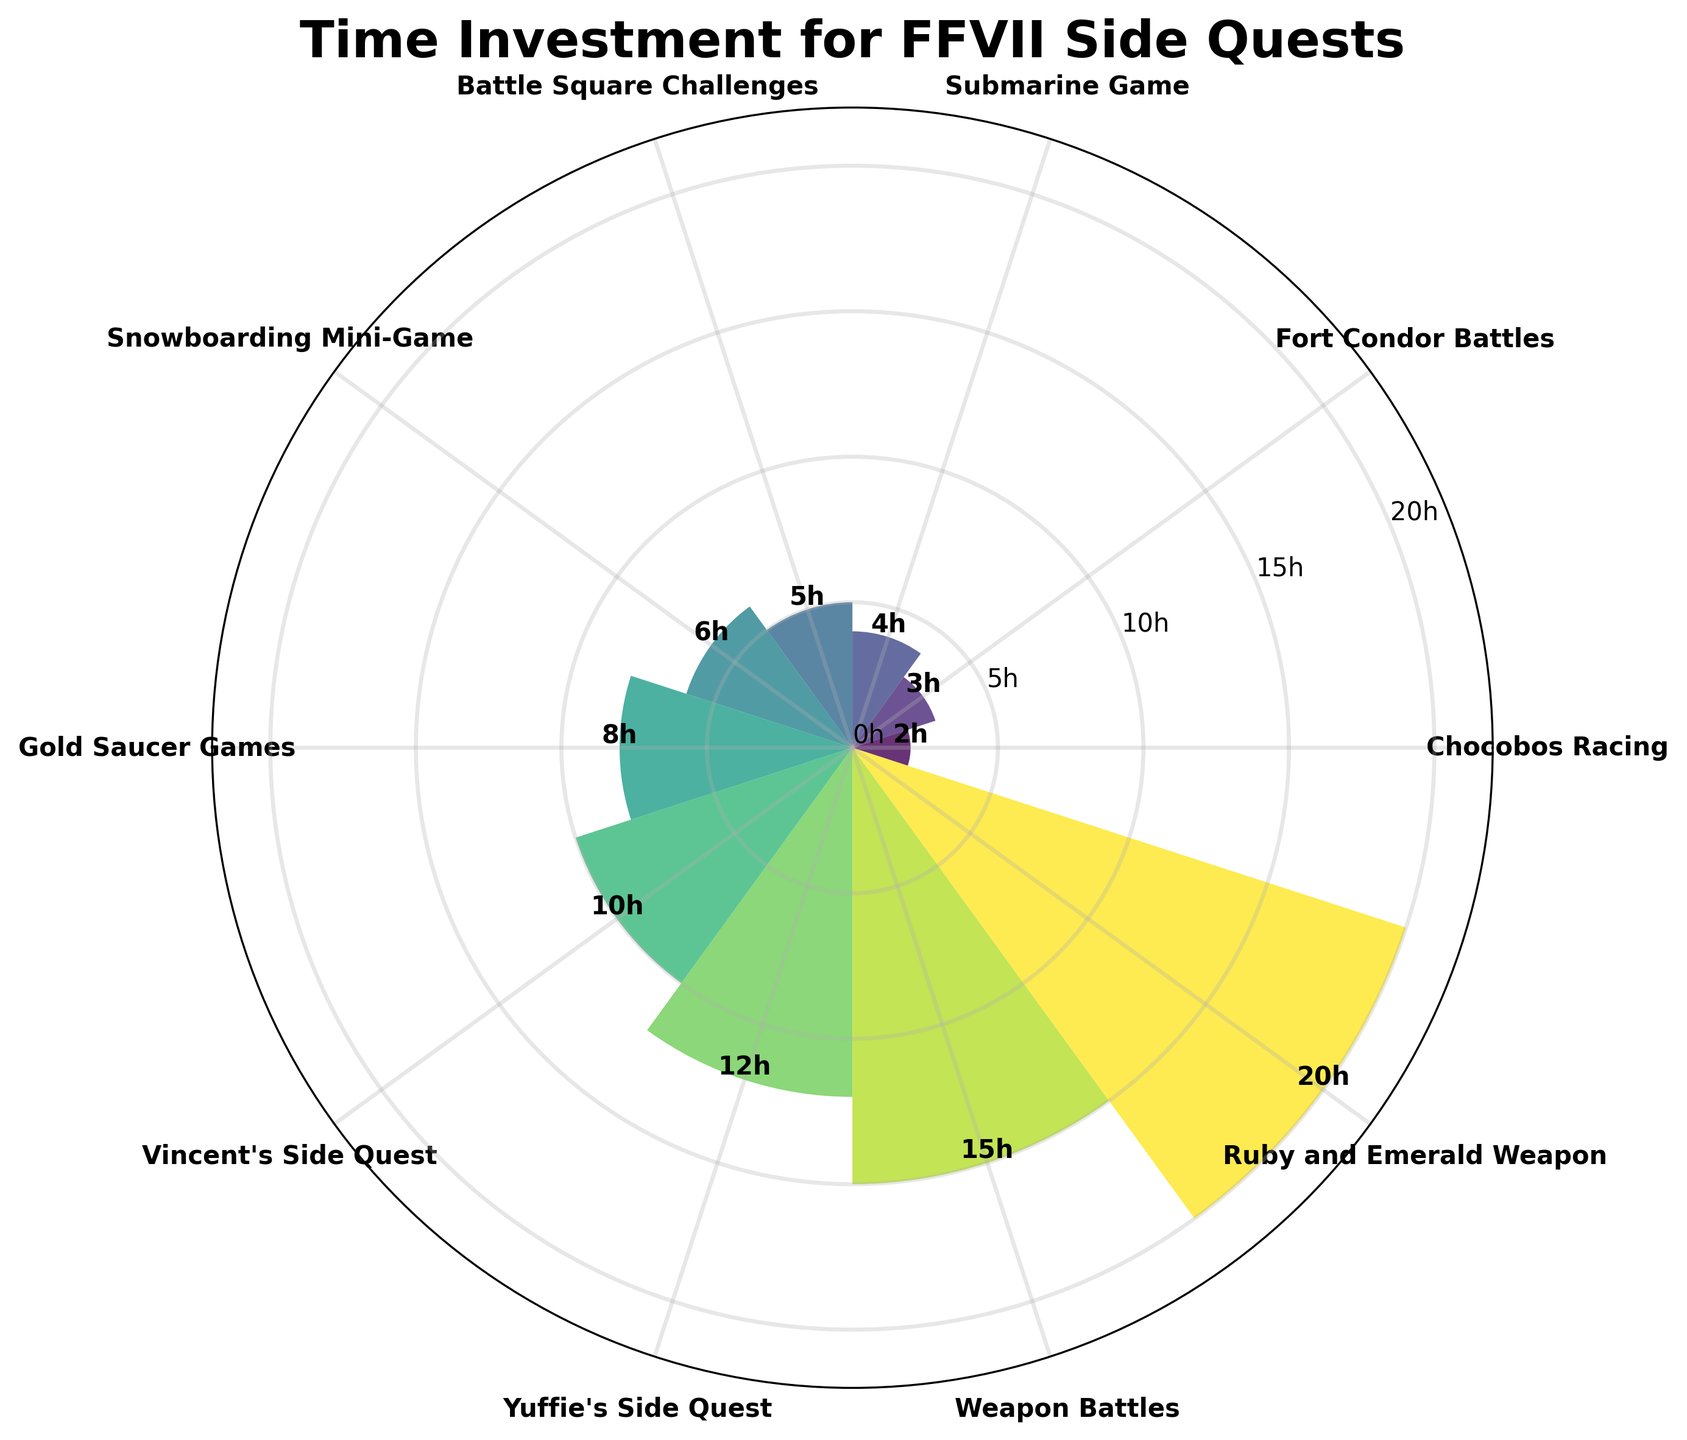What is the title of the chart? The title is usually found at the top of the chart and summarises the main topic. In this case, it should be specific to the activity durations.
Answer: Time Investment for FFVII Side Quests What is the shortest activity and its duration? At the start of the fan chart, the smallest bar represents the shortest activity and its duration.
Answer: Chocobos Racing, 2 hours What is the longest activity and its duration? The tallest bar on the chart shows the activity with the longest duration.
Answer: Ruby and Emerald Weapon, 20 hours How many activities take more than 10 hours to complete? Count the bars taller than the 10-hour mark.
Answer: 4 activities What is the combined time investment for Vincent's Side Quest and Yuffie's Side Quest? Add the durations of Vincent's Side Quest and Yuffie's Side Quest: 10 + 12.
Answer: 22 hours Which activity takes more time, the Battle Square Challenges or Gold Saucer Games? Compare the height of the bars for Battle Square Challenges and Gold Saucer Games.
Answer: Gold Saucer Games How much longer does the Ruby and Emerald Weapon take compared to Weapon Battles? Subtract the duration of Weapon Battles from the duration of Ruby and Emerald Weapon: 20 - 15.
Answer: 5 hours What is the average time needed to complete Snowboarding Mini-Game, Fort Condor Battles, and Submarine Game? Add their times and divide by the number of activities: (6 + 3 + 4) / 3.
Answer: 4.33 hours Which activities take less than 5 hours? Identify the activities with bars shorter than the 5-hour bar: Chocobos Racing, Fort Condor Battles, Submarine Game.
Answer: Chocobos Racing, Fort Condor Battles, Submarine Game What is the range of time investments for all activities? Subtract the shortest duration from the longest duration: 20 - 2.
Answer: 18 hours 